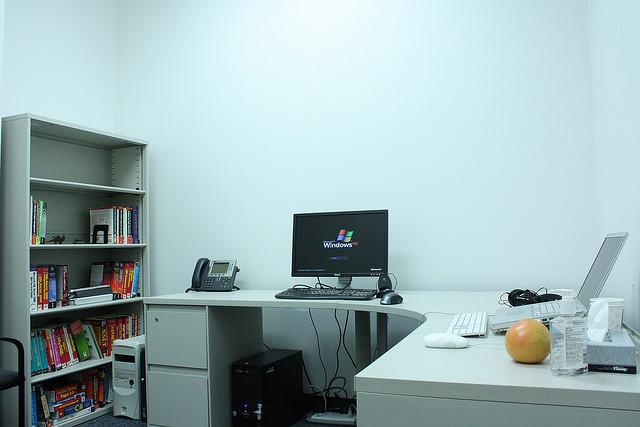What general subject do the books in the bookcase to the left of the phone cover? Please explain your reasoning. information technology. The subject is it. 